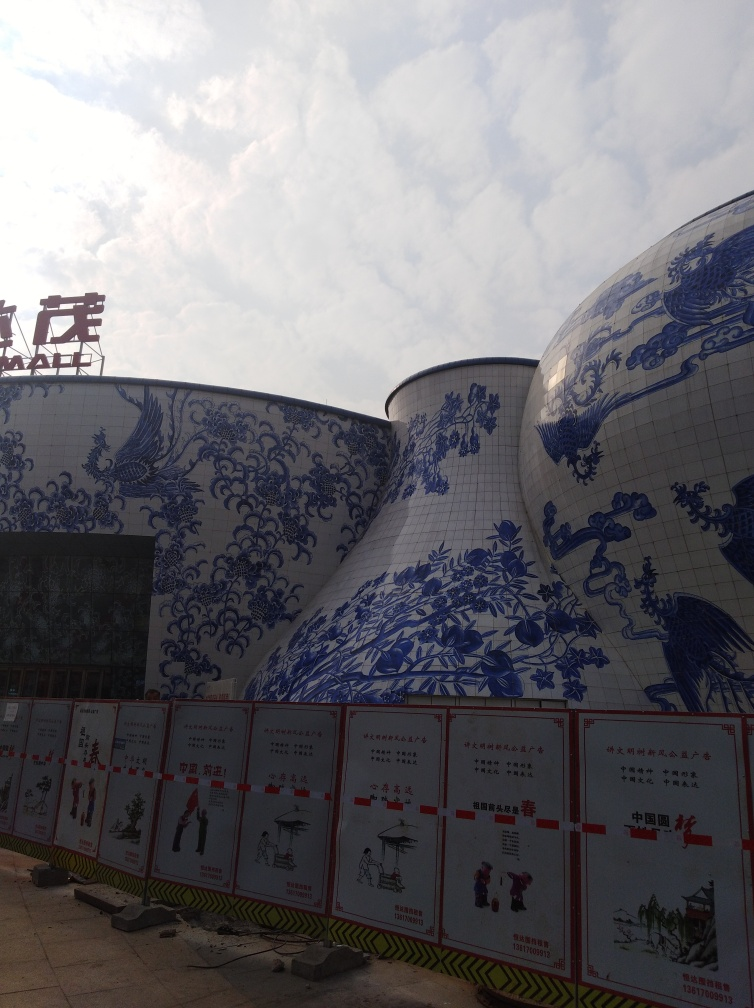What does the presence of these buildings indicate about the local culture or city planning? The architectural design and effort to incorporate cultural artistry into these buildings suggest a strong valuing of traditional aesthetics and perhaps a blend of modernity with cultural heritage. Such buildings could serve as landmarks and points of interest that enhance the cultural richness of a city and express a commitment to preserving cultural identity within an urban environment. 